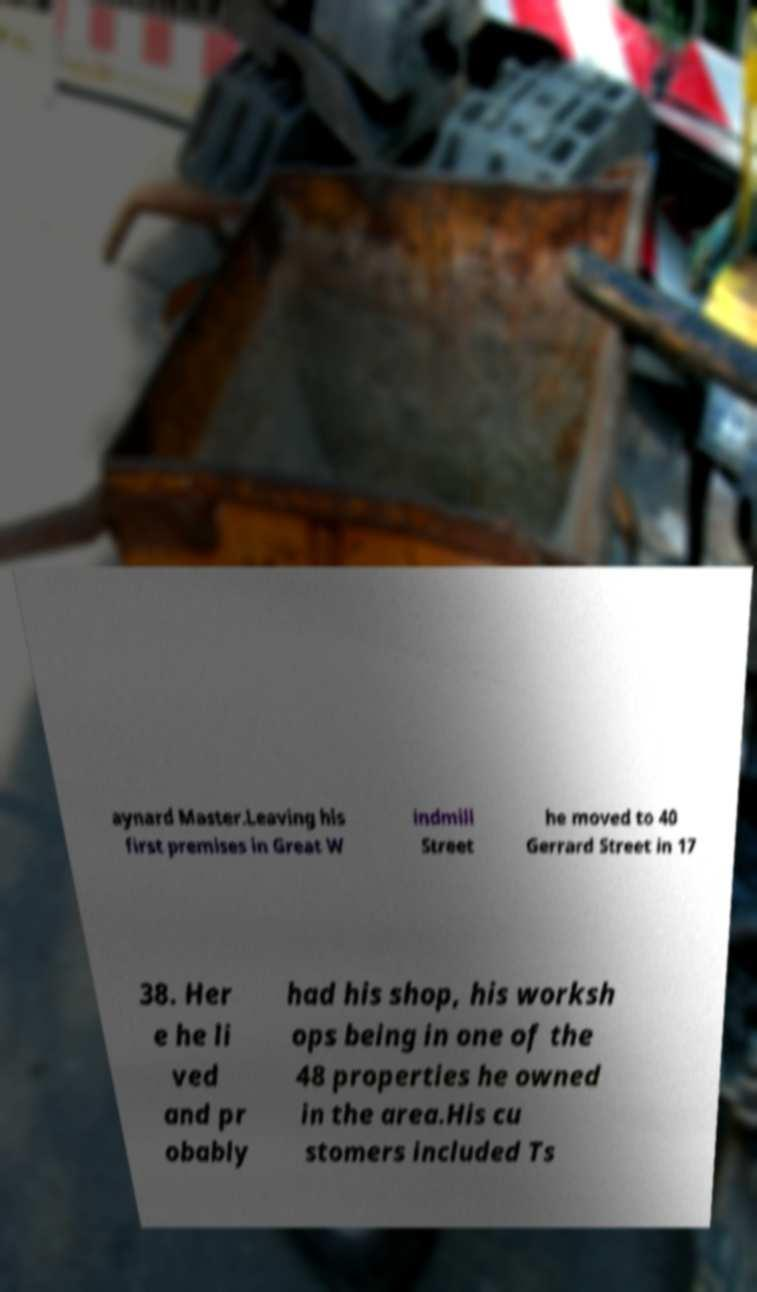I need the written content from this picture converted into text. Can you do that? aynard Master.Leaving his first premises in Great W indmill Street he moved to 40 Gerrard Street in 17 38. Her e he li ved and pr obably had his shop, his worksh ops being in one of the 48 properties he owned in the area.His cu stomers included Ts 